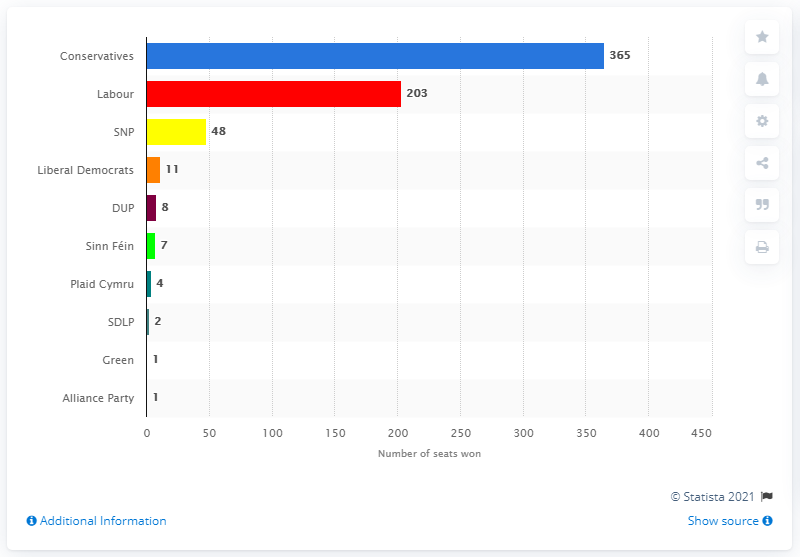Indicate a few pertinent items in this graphic. The Conservatives won a total of 365 seats out of 650 in the most recent election. 